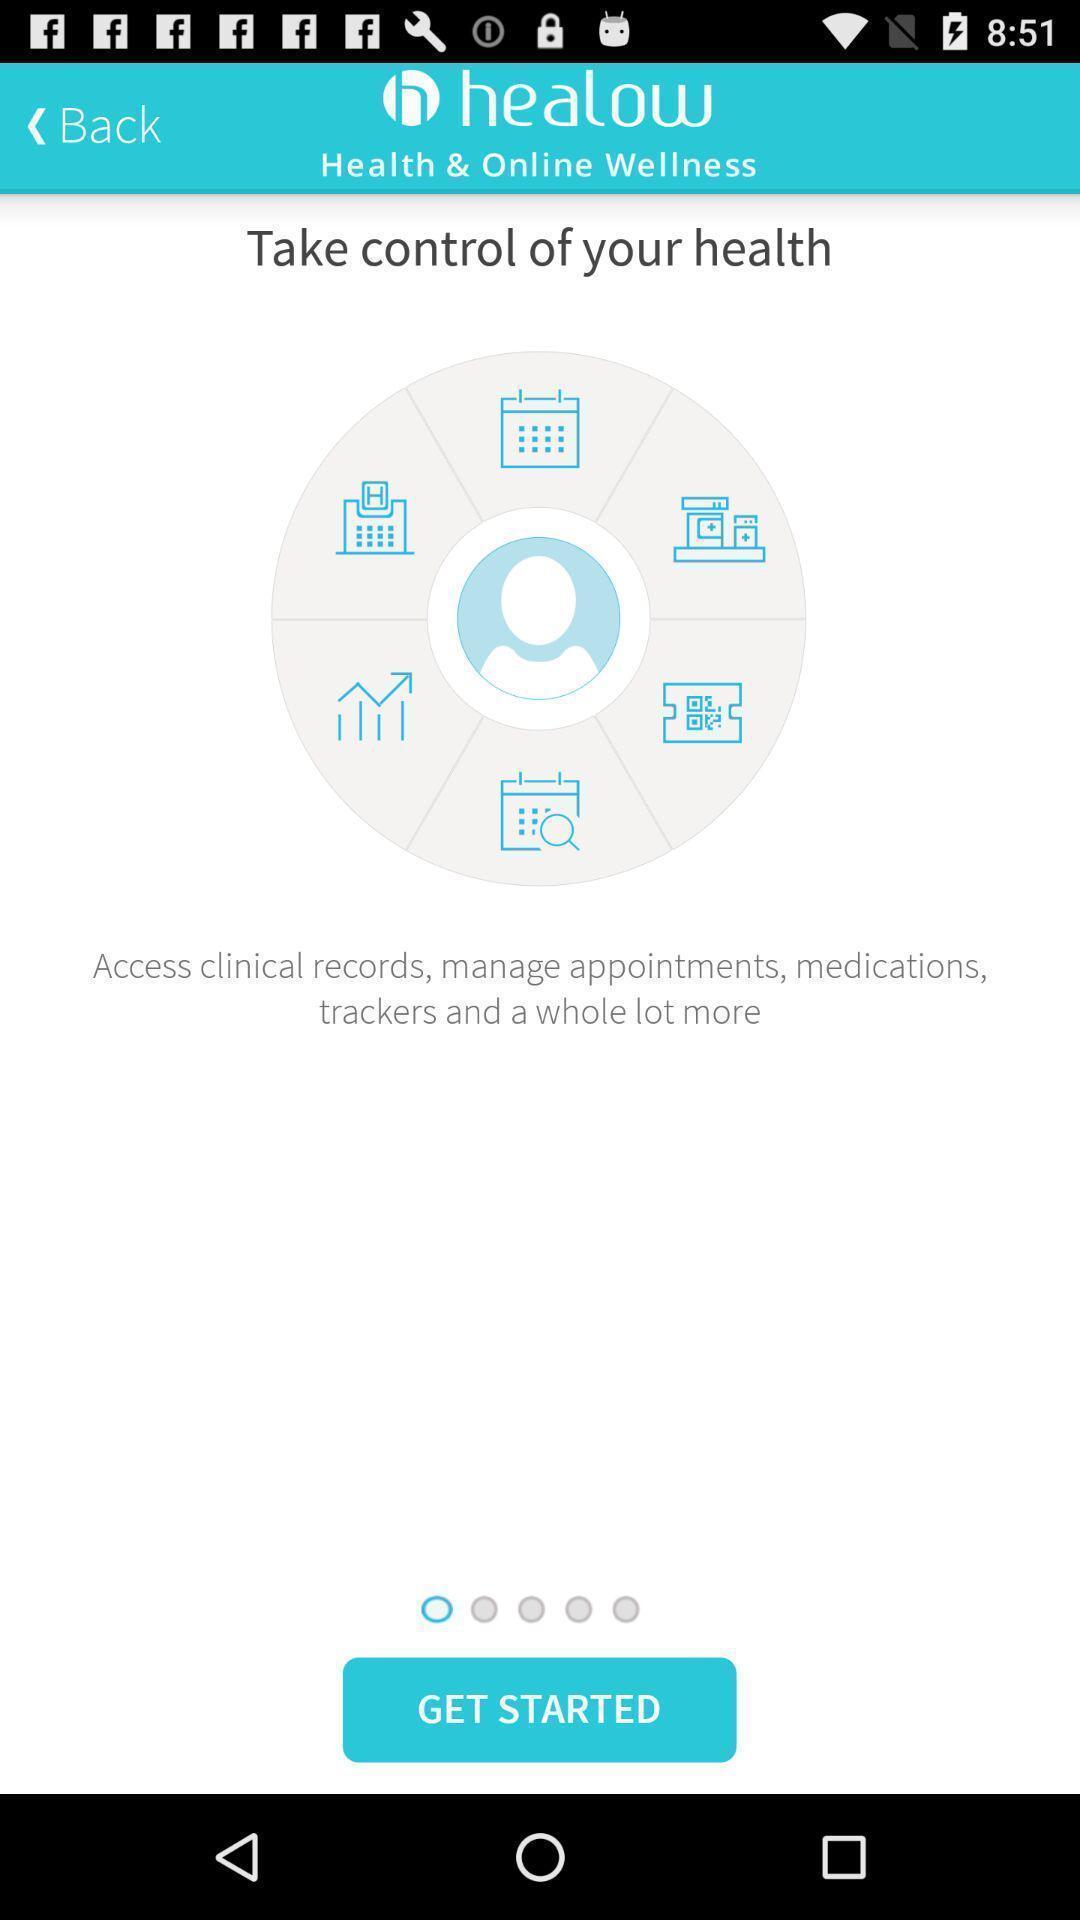Tell me about the visual elements in this screen capture. Welcome page of a health care app. 